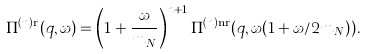<formula> <loc_0><loc_0><loc_500><loc_500>\Pi ^ { ( n ) \text {r} } ( q , \omega ) = \left ( 1 + \frac { \omega } { m _ { N } } \right ) ^ { n + 1 } \Pi ^ { ( n ) \text {nr} } ( q , \omega ( 1 + \omega / 2 m _ { N } ) ) .</formula> 